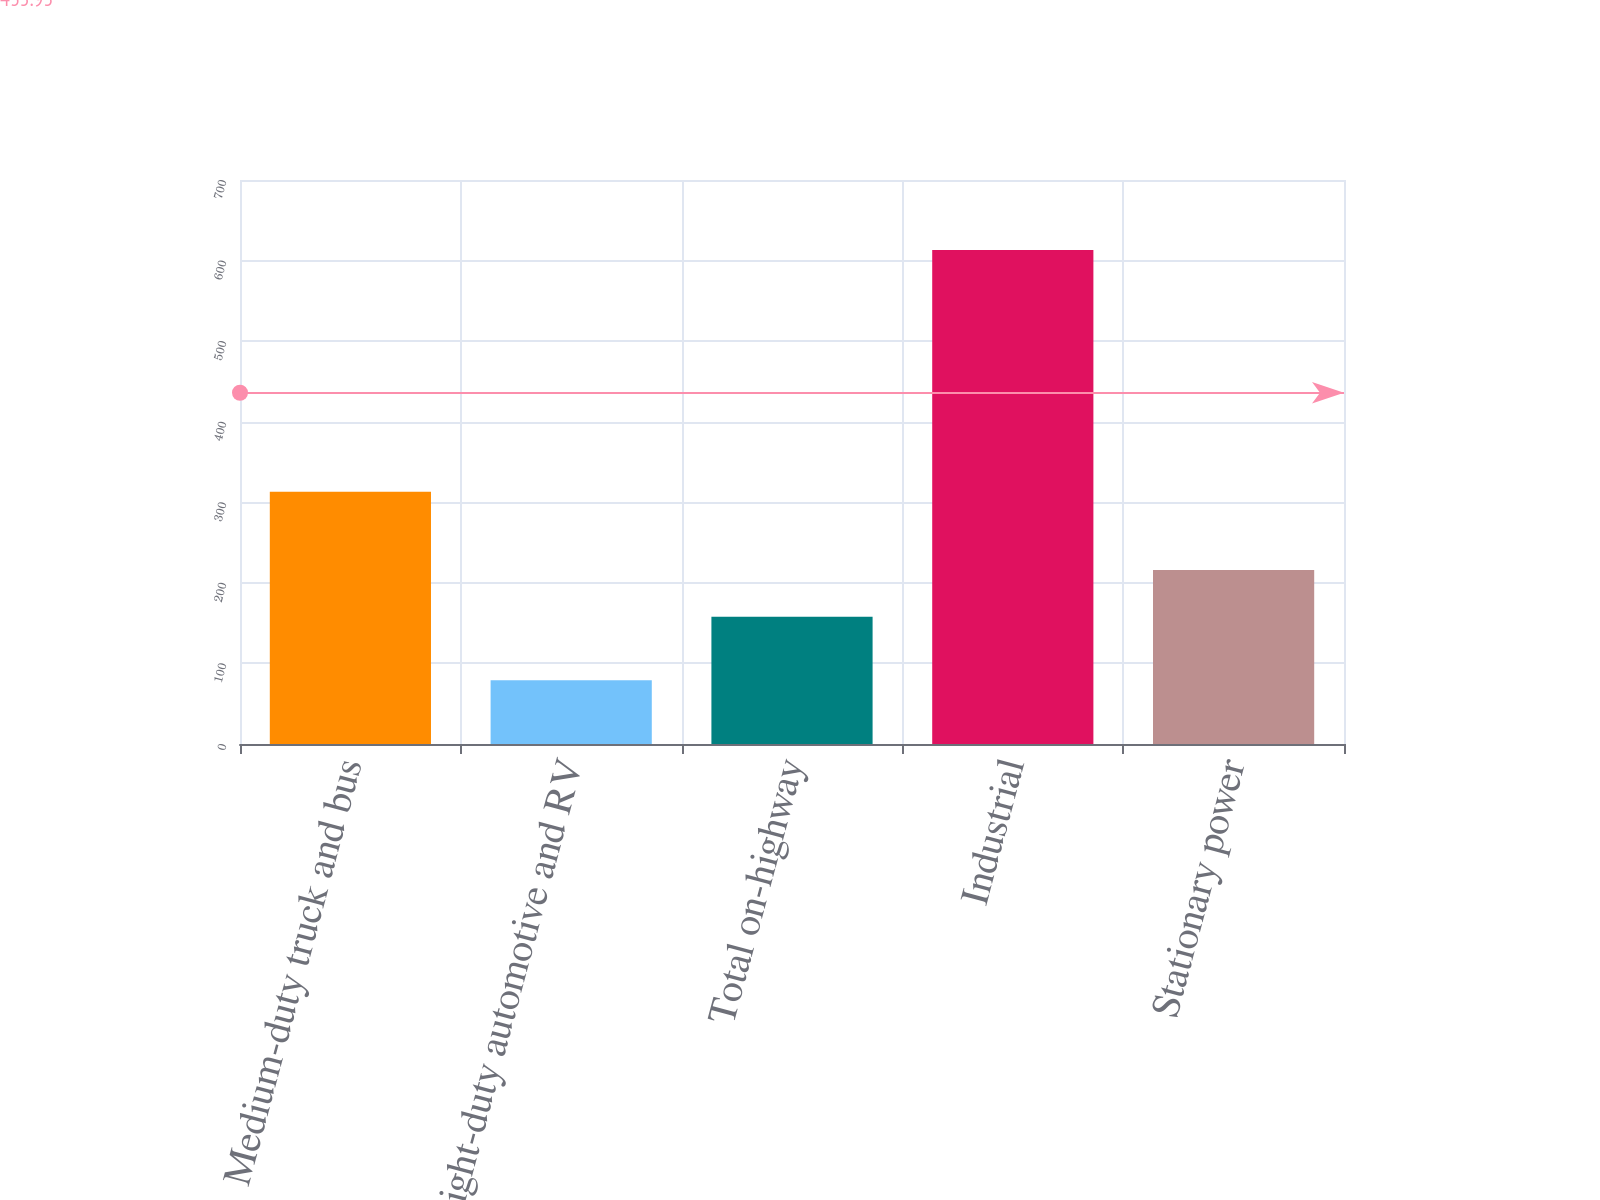Convert chart. <chart><loc_0><loc_0><loc_500><loc_500><bar_chart><fcel>Medium-duty truck and bus<fcel>Light-duty automotive and RV<fcel>Total on-highway<fcel>Industrial<fcel>Stationary power<nl><fcel>313<fcel>79<fcel>158<fcel>613<fcel>216<nl></chart> 